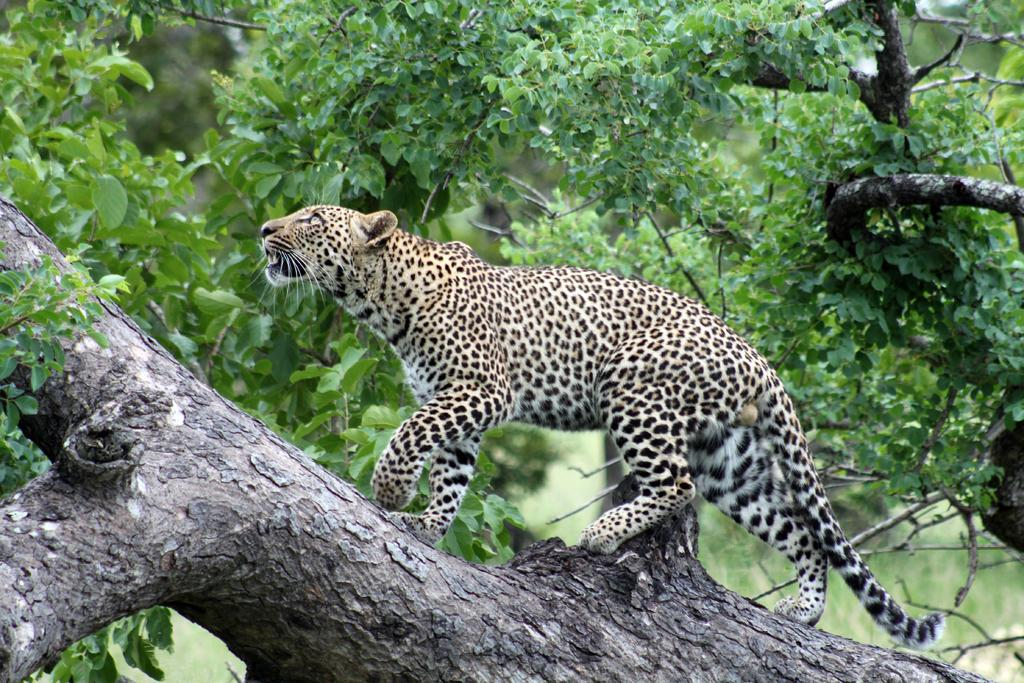What animal is the main subject of the image? There is a cheetah in the image. What is the cheetah doing in the image? The cheetah is walking on a tree. What can be seen in the background of the image? There are trees in the background of the image. How many ladybugs are crawling on the cheetah's tail in the image? There are no ladybugs present in the image, so it is not possible to determine how many might be crawling on the cheetah's tail. 